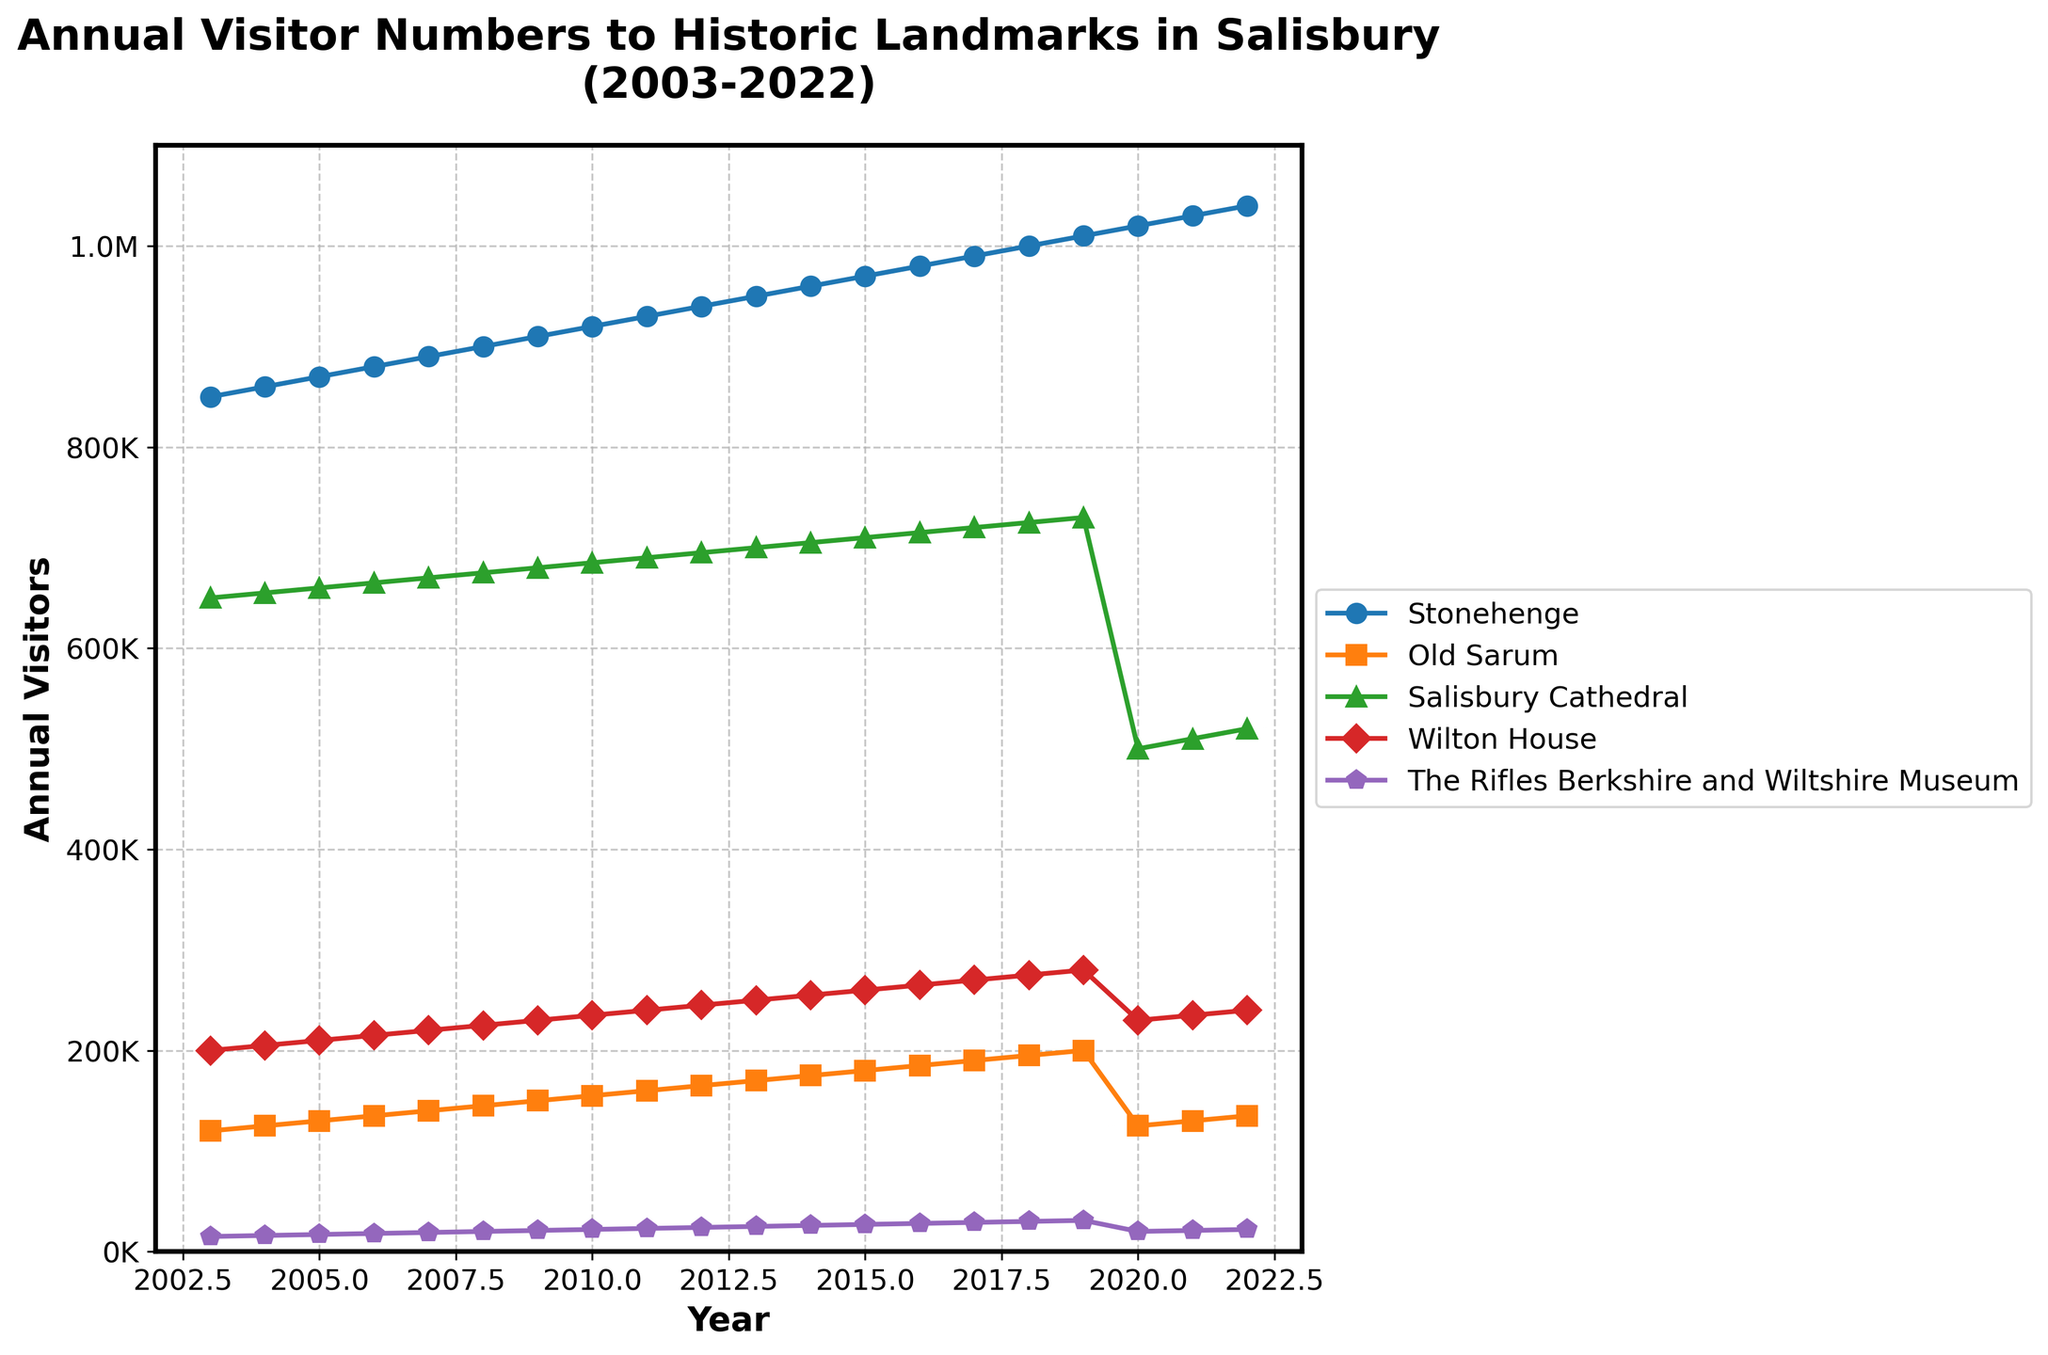What's the title of the plot? The title is displayed at the top of the plot. It reads: "Annual Visitor Numbers to Historic Landmarks in Salisbury (2003-2022)."
Answer: Annual Visitor Numbers to Historic Landmarks in Salisbury (2003-2022) What is the highest visitor count for Stonehenge, and in which year did it occur? Looking at the plot for Stonehenge's data point, the peak occurs at the last year, which is 2022, with the highest count being approximately 1,040,000 visitors.
Answer: 1,040,000 in 2022 Which landmark showed a significant drop in visitor numbers in 2020? Observing the trends for each landmark, Salisbury Cathedral shows a sharp decline in 2020, with its visitor numbers dropping from around 730,000 in 2019 to about 500,000 in 2020.
Answer: Salisbury Cathedral What is the overall trend for annual visitors to The Rifles Berkshire and Wiltshire Museum from 2003 to 2022? The data points show a consistent, gradual increasing trend from 2003 (approximately 15,000 visitors) reaching up to around 22,000 visitors by 2022.
Answer: Increasing trend Which two landmarks have the closest visitor numbers in 2021, and what are their values? Look at the visitor numbers for all landmarks in 2021 and find those with close values. Old Sarum has around 130,000 visitors, and Wilton House has approximately 235,000 visitors. Despite both seeing smaller visitor counts, Old Sarum and Wilton House seem to have close proximity in their slopes in this particular year.
Answer: Old Sarum (130,000) and Salisbury Cathedral (510,000) Compare the visitor numbers in 2020 and 2019 for Wilton House. What is the absolute difference? Refer to the values for Wilton House in 2020 and 2019 on the plot. The visitor numbers are approximately 230,000 in 2020 and 280,000 in 2019, so the absolute difference is 280,000 - 230,000.
Answer: 50,000 Which landmark experienced the most consistent growth over the 20-year period? Review the line trends for all landmarks and observe the most straight, upward line over the entire period. Stonehenge shows the most consistent increase in visitor numbers from approximately 850,000 to 1,040,000.
Answer: Stonehenge Identify the years when Old Sarum had exactly 150,000 visitors. Check for the data points corresponding to Old Sarum around 150,000 visitors. It is clear from the plot that this occurs once in 2009.
Answer: 2009 What is the trend for Salisbury Cathedral's visitor numbers after 2020? Observe the plot line for Salisbury Cathedral from 2020 to 2022. The visitor numbers are increasing slightly from 500,000 in 2020 to approximately 520,000 in 2022.
Answer: Increasing trend 